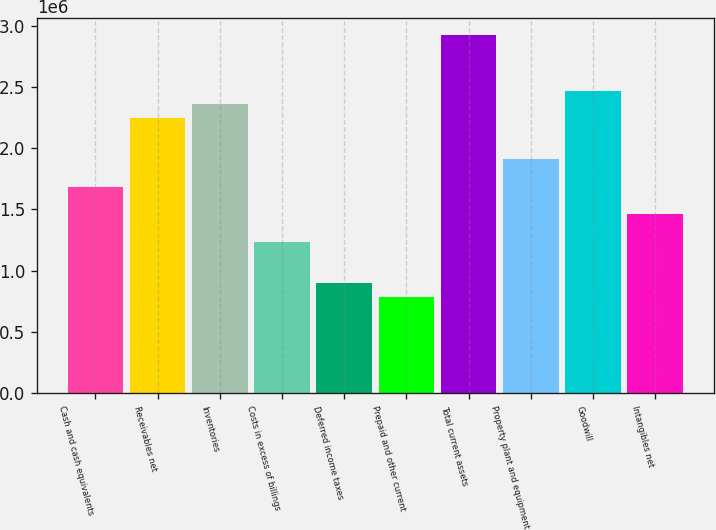Convert chart to OTSL. <chart><loc_0><loc_0><loc_500><loc_500><bar_chart><fcel>Cash and cash equivalents<fcel>Receivables net<fcel>Inventories<fcel>Costs in excess of billings<fcel>Deferred income taxes<fcel>Prepaid and other current<fcel>Total current assets<fcel>Property plant and equipment<fcel>Goodwill<fcel>Intangibles net<nl><fcel>1.68505e+06<fcel>2.24646e+06<fcel>2.35874e+06<fcel>1.23592e+06<fcel>899069<fcel>786787<fcel>2.92015e+06<fcel>1.90961e+06<fcel>2.47102e+06<fcel>1.46048e+06<nl></chart> 